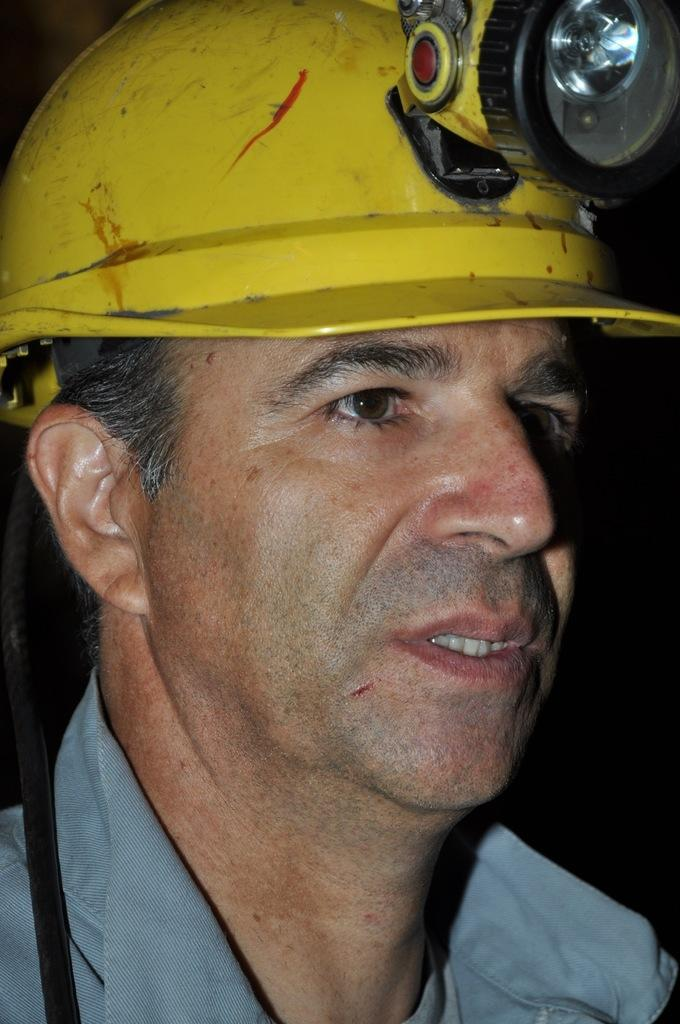Who is present in the image? There is a man in the image. What is the man wearing on his head? The man is wearing a helmet. Is there any additional equipment attached to the helmet? Yes, there is a light attached to the helmet. What type of apples is the man eating in the image? There are no apples present in the image; the man is wearing a helmet with a light attached to it. How does the man use his mouth in the image? The facts provided do not mention the man's mouth or any actions related to it, so we cannot determine how he uses his mouth in the image. 